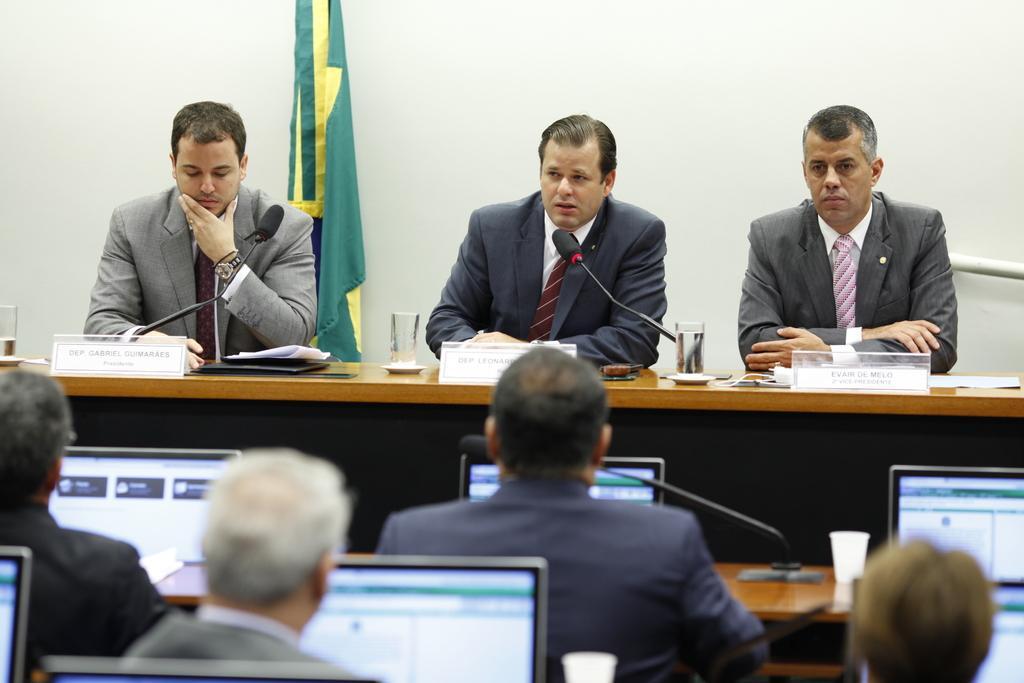Please provide a concise description of this image. In this image I can see three persons wearing shirts, ties and blazers are sitting in front of the desk and on the desk I can see three boards, two glasses and few papers. I can see microphones in front of them. I can see number of persons sitting and laptops in front of them. In the background I can see the flag and the white colored surface. 